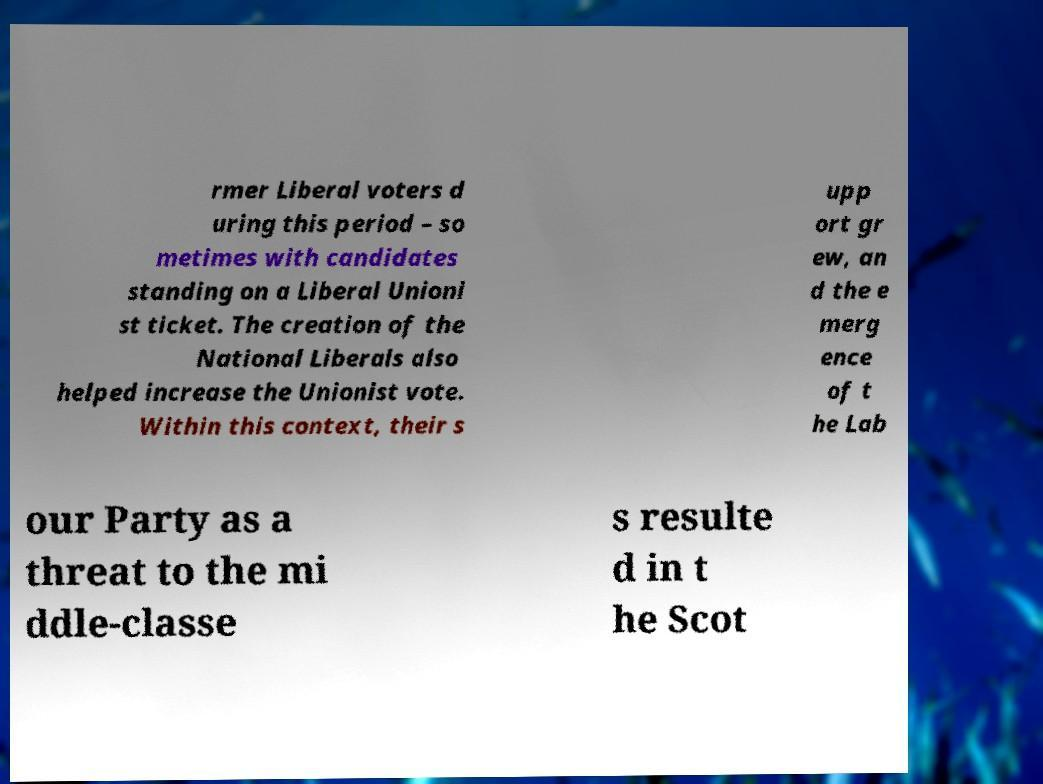Please read and relay the text visible in this image. What does it say? rmer Liberal voters d uring this period – so metimes with candidates standing on a Liberal Unioni st ticket. The creation of the National Liberals also helped increase the Unionist vote. Within this context, their s upp ort gr ew, an d the e merg ence of t he Lab our Party as a threat to the mi ddle-classe s resulte d in t he Scot 